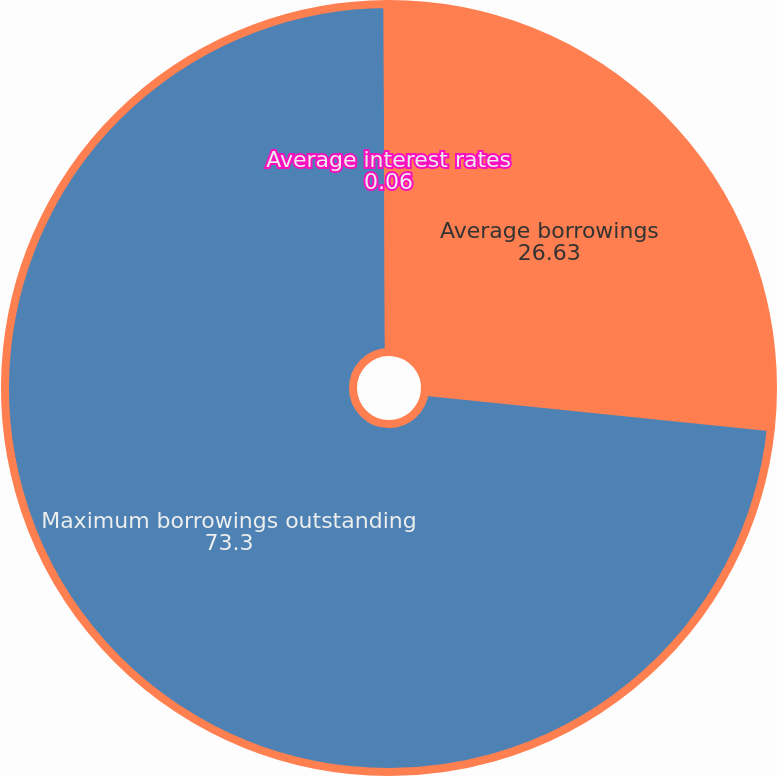Convert chart to OTSL. <chart><loc_0><loc_0><loc_500><loc_500><pie_chart><fcel>Average borrowings<fcel>Maximum borrowings outstanding<fcel>Average interest rates<nl><fcel>26.63%<fcel>73.3%<fcel>0.06%<nl></chart> 